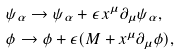Convert formula to latex. <formula><loc_0><loc_0><loc_500><loc_500>& \psi _ { \alpha } \to \psi _ { \alpha } + \epsilon \, x ^ { \mu } \partial _ { \mu } \psi _ { \alpha } , \\ & \phi \to \phi + \epsilon ( M + x ^ { \mu } \partial _ { \mu } \phi ) ,</formula> 